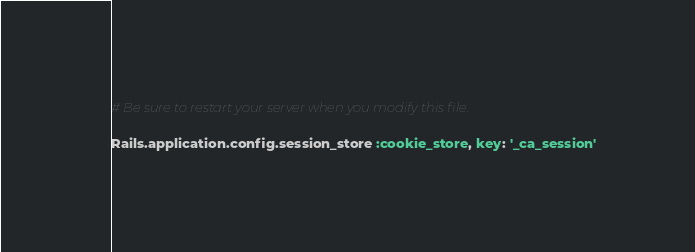<code> <loc_0><loc_0><loc_500><loc_500><_Ruby_># Be sure to restart your server when you modify this file.

Rails.application.config.session_store :cookie_store, key: '_ca_session'
</code> 